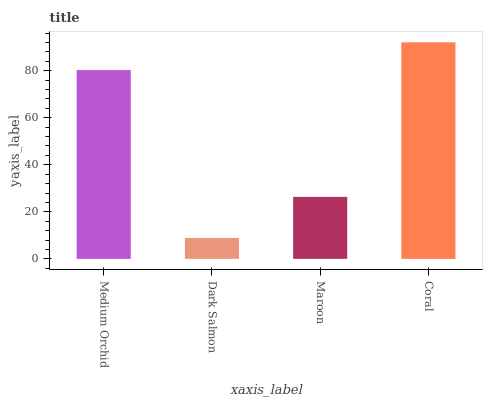Is Maroon the minimum?
Answer yes or no. No. Is Maroon the maximum?
Answer yes or no. No. Is Maroon greater than Dark Salmon?
Answer yes or no. Yes. Is Dark Salmon less than Maroon?
Answer yes or no. Yes. Is Dark Salmon greater than Maroon?
Answer yes or no. No. Is Maroon less than Dark Salmon?
Answer yes or no. No. Is Medium Orchid the high median?
Answer yes or no. Yes. Is Maroon the low median?
Answer yes or no. Yes. Is Dark Salmon the high median?
Answer yes or no. No. Is Medium Orchid the low median?
Answer yes or no. No. 